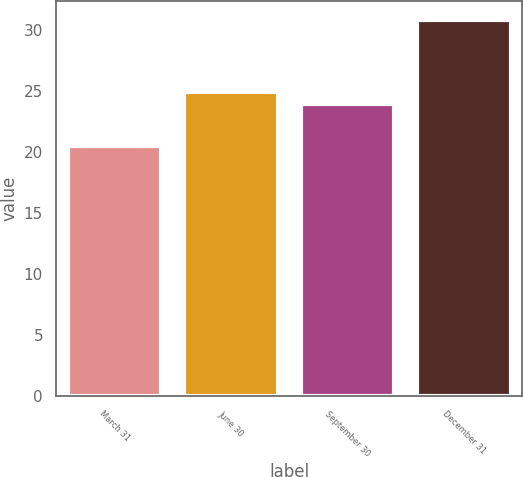Convert chart. <chart><loc_0><loc_0><loc_500><loc_500><bar_chart><fcel>March 31<fcel>June 30<fcel>September 30<fcel>December 31<nl><fcel>20.5<fcel>24.93<fcel>23.9<fcel>30.8<nl></chart> 